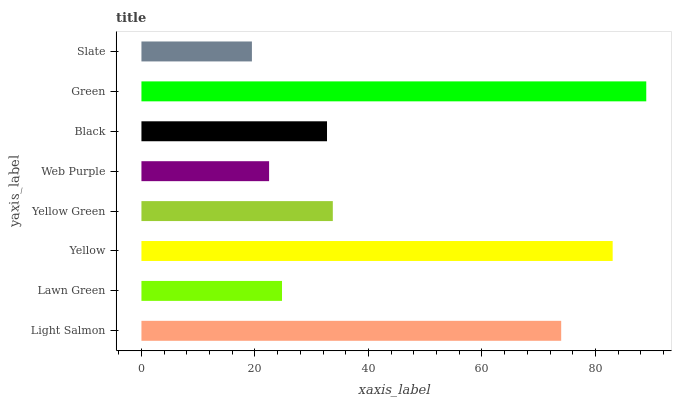Is Slate the minimum?
Answer yes or no. Yes. Is Green the maximum?
Answer yes or no. Yes. Is Lawn Green the minimum?
Answer yes or no. No. Is Lawn Green the maximum?
Answer yes or no. No. Is Light Salmon greater than Lawn Green?
Answer yes or no. Yes. Is Lawn Green less than Light Salmon?
Answer yes or no. Yes. Is Lawn Green greater than Light Salmon?
Answer yes or no. No. Is Light Salmon less than Lawn Green?
Answer yes or no. No. Is Yellow Green the high median?
Answer yes or no. Yes. Is Black the low median?
Answer yes or no. Yes. Is Yellow the high median?
Answer yes or no. No. Is Lawn Green the low median?
Answer yes or no. No. 